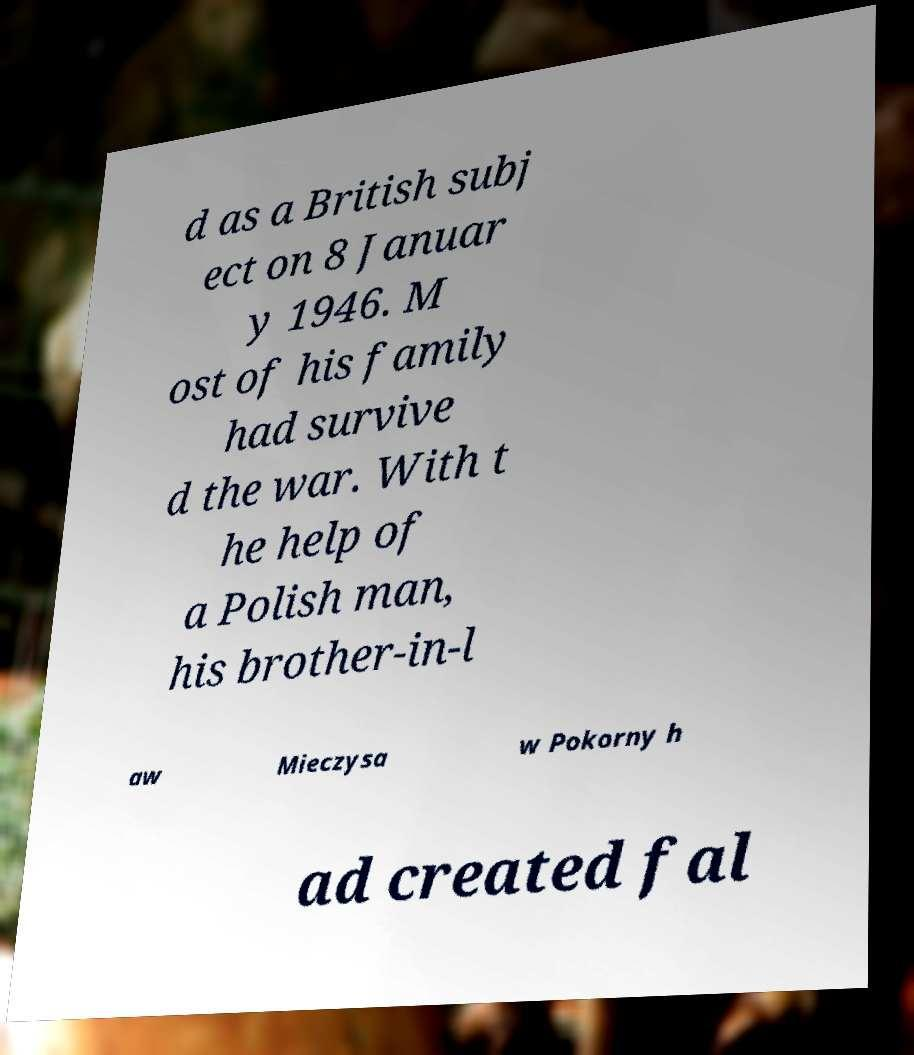Can you read and provide the text displayed in the image?This photo seems to have some interesting text. Can you extract and type it out for me? d as a British subj ect on 8 Januar y 1946. M ost of his family had survive d the war. With t he help of a Polish man, his brother-in-l aw Mieczysa w Pokorny h ad created fal 